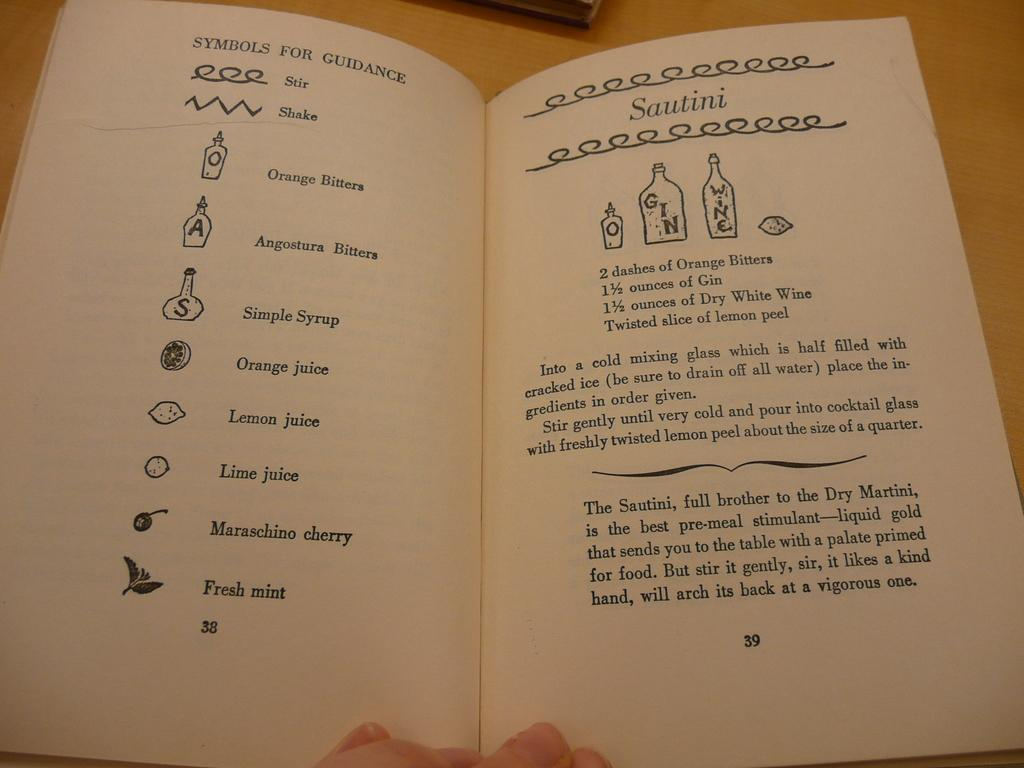<image>
Write a terse but informative summary of the picture. an open book with the drawing of fruits on the left and direction how to prepare the items. 